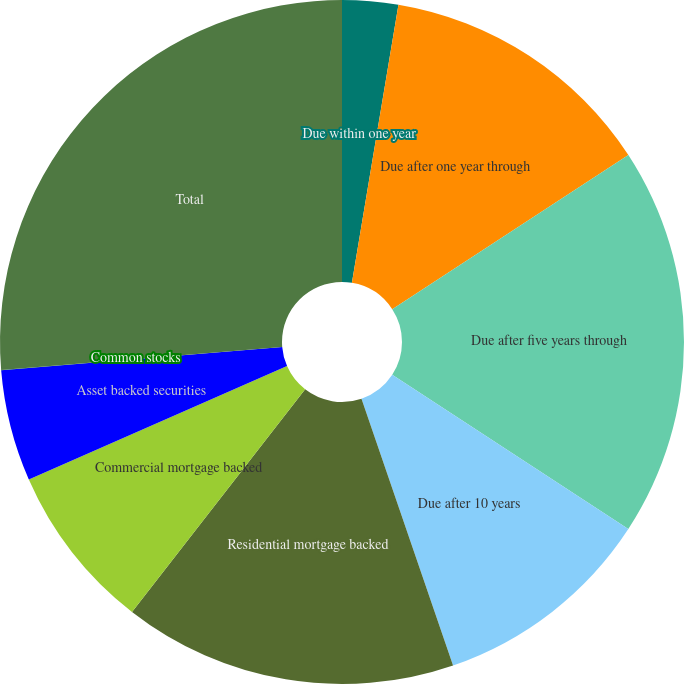Convert chart. <chart><loc_0><loc_0><loc_500><loc_500><pie_chart><fcel>Due within one year<fcel>Due after one year through<fcel>Due after five years through<fcel>Due after 10 years<fcel>Residential mortgage backed<fcel>Commercial mortgage backed<fcel>Asset backed securities<fcel>Common stocks<fcel>Total<nl><fcel>2.64%<fcel>13.16%<fcel>18.42%<fcel>10.53%<fcel>15.79%<fcel>7.9%<fcel>5.27%<fcel>0.01%<fcel>26.31%<nl></chart> 